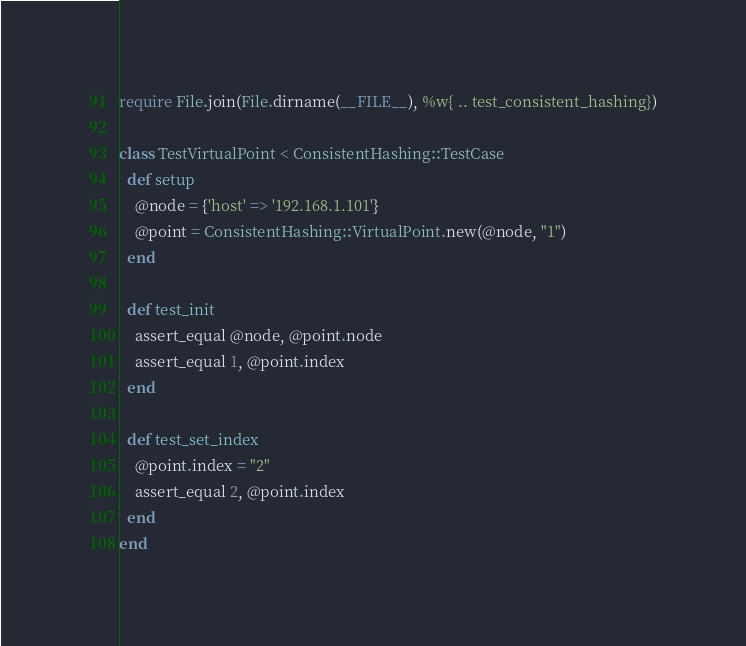Convert code to text. <code><loc_0><loc_0><loc_500><loc_500><_Ruby_>require File.join(File.dirname(__FILE__), %w{ .. test_consistent_hashing})

class TestVirtualPoint < ConsistentHashing::TestCase
  def setup
    @node = {'host' => '192.168.1.101'}
    @point = ConsistentHashing::VirtualPoint.new(@node, "1")
  end

  def test_init
    assert_equal @node, @point.node
    assert_equal 1, @point.index
  end

  def test_set_index
    @point.index = "2"
    assert_equal 2, @point.index
  end
end
</code> 